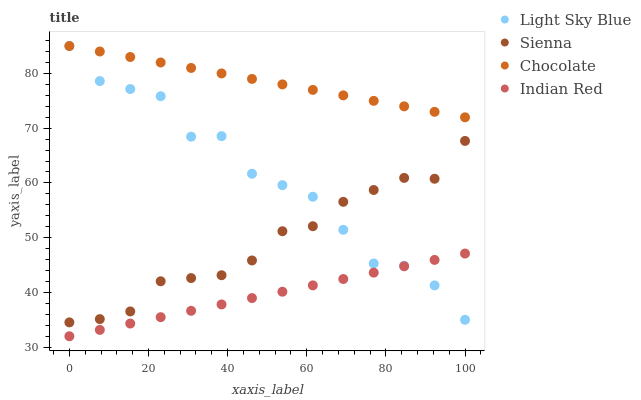Does Indian Red have the minimum area under the curve?
Answer yes or no. Yes. Does Chocolate have the maximum area under the curve?
Answer yes or no. Yes. Does Light Sky Blue have the minimum area under the curve?
Answer yes or no. No. Does Light Sky Blue have the maximum area under the curve?
Answer yes or no. No. Is Indian Red the smoothest?
Answer yes or no. Yes. Is Light Sky Blue the roughest?
Answer yes or no. Yes. Is Light Sky Blue the smoothest?
Answer yes or no. No. Is Indian Red the roughest?
Answer yes or no. No. Does Indian Red have the lowest value?
Answer yes or no. Yes. Does Light Sky Blue have the lowest value?
Answer yes or no. No. Does Chocolate have the highest value?
Answer yes or no. Yes. Does Indian Red have the highest value?
Answer yes or no. No. Is Indian Red less than Chocolate?
Answer yes or no. Yes. Is Chocolate greater than Indian Red?
Answer yes or no. Yes. Does Indian Red intersect Light Sky Blue?
Answer yes or no. Yes. Is Indian Red less than Light Sky Blue?
Answer yes or no. No. Is Indian Red greater than Light Sky Blue?
Answer yes or no. No. Does Indian Red intersect Chocolate?
Answer yes or no. No. 